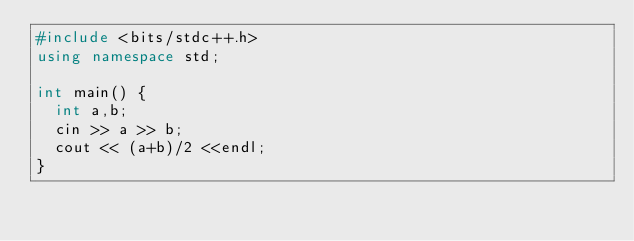Convert code to text. <code><loc_0><loc_0><loc_500><loc_500><_C++_>#include <bits/stdc++.h>
using namespace std;

int main() {
  int a,b;
  cin >> a >> b;
  cout << (a+b)/2 <<endl;
}
</code> 